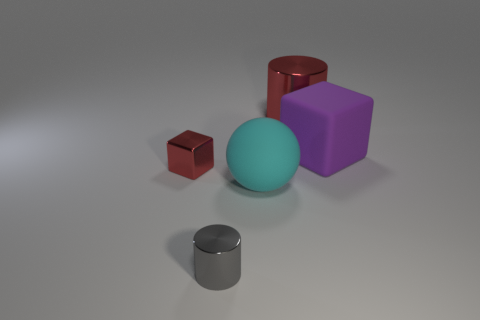Is there anything else that has the same shape as the cyan matte thing?
Provide a succinct answer. No. Is the number of rubber things left of the large metal object greater than the number of large green cylinders?
Provide a short and direct response. Yes. What is the material of the red thing on the right side of the metal cube?
Offer a very short reply. Metal. What number of tiny red blocks have the same material as the purple thing?
Provide a succinct answer. 0. There is a thing that is both right of the gray thing and in front of the red metal cube; what is its shape?
Keep it short and to the point. Sphere. How many things are purple matte cubes behind the small red shiny cube or metallic things that are behind the large ball?
Keep it short and to the point. 3. Are there the same number of purple rubber things that are in front of the tiny red metal thing and purple rubber objects to the right of the matte block?
Your response must be concise. Yes. What shape is the large object right of the shiny cylinder that is behind the small metal cube?
Provide a succinct answer. Cube. Is there another shiny object of the same shape as the tiny gray metallic thing?
Provide a short and direct response. Yes. How many big red shiny cylinders are there?
Your answer should be very brief. 1. 